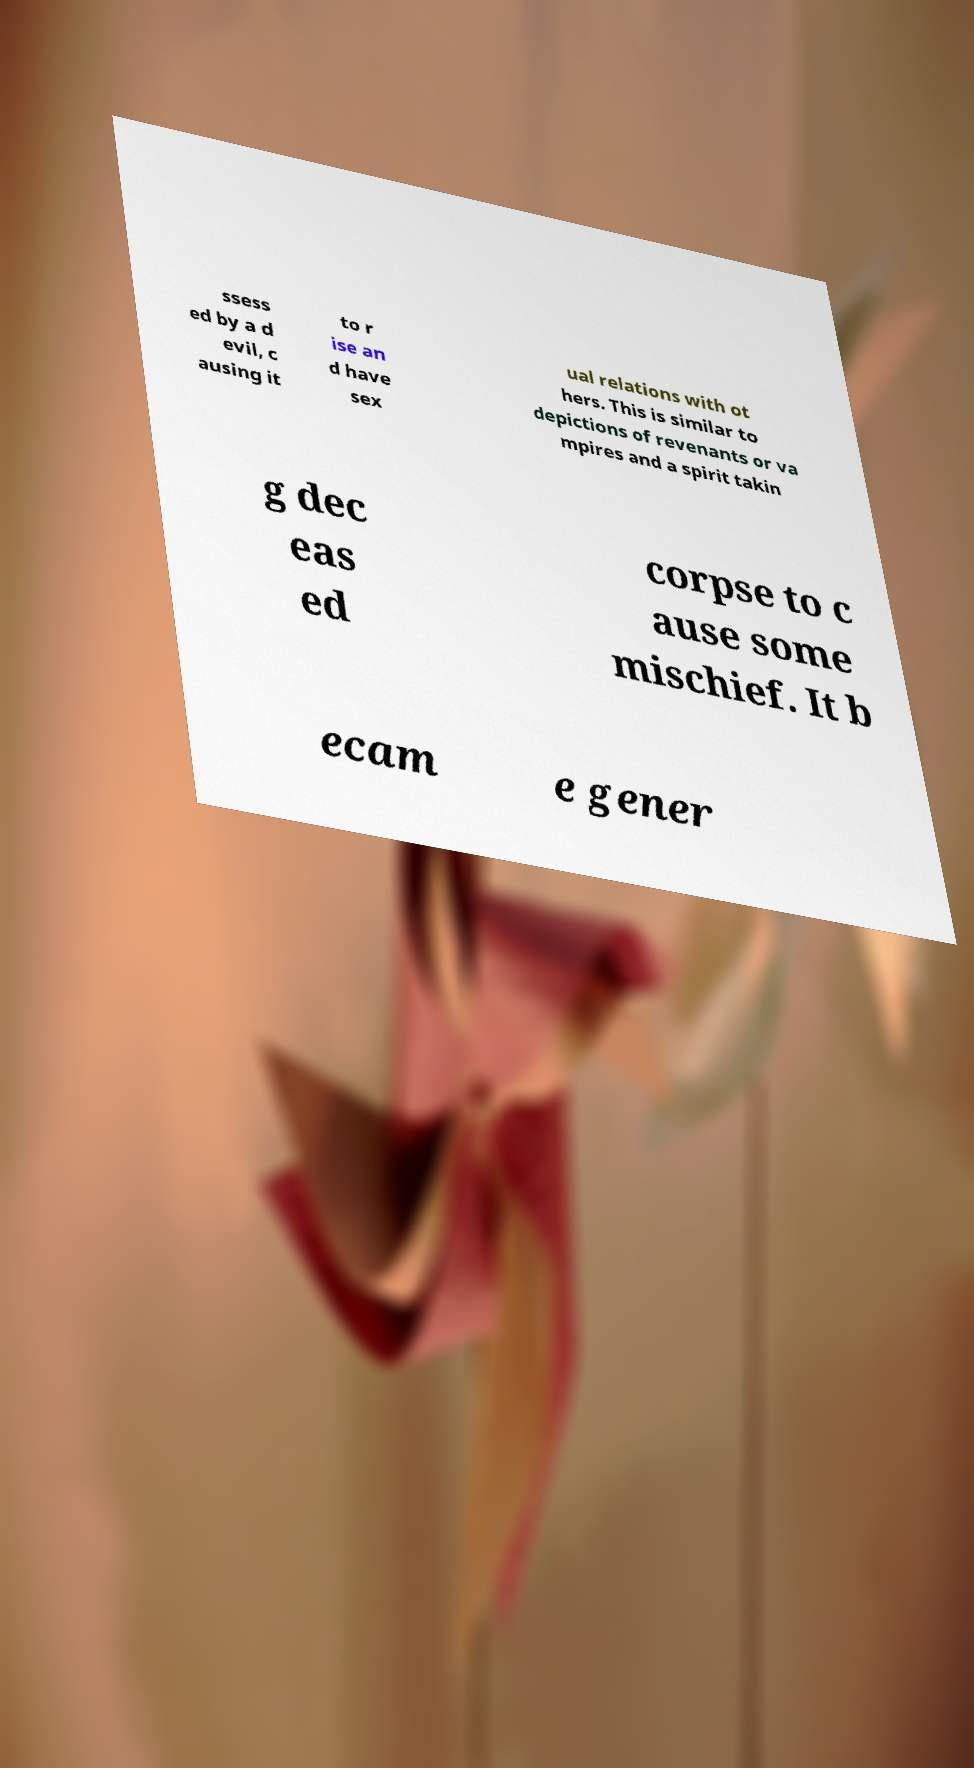Please read and relay the text visible in this image. What does it say? ssess ed by a d evil, c ausing it to r ise an d have sex ual relations with ot hers. This is similar to depictions of revenants or va mpires and a spirit takin g dec eas ed corpse to c ause some mischief. It b ecam e gener 